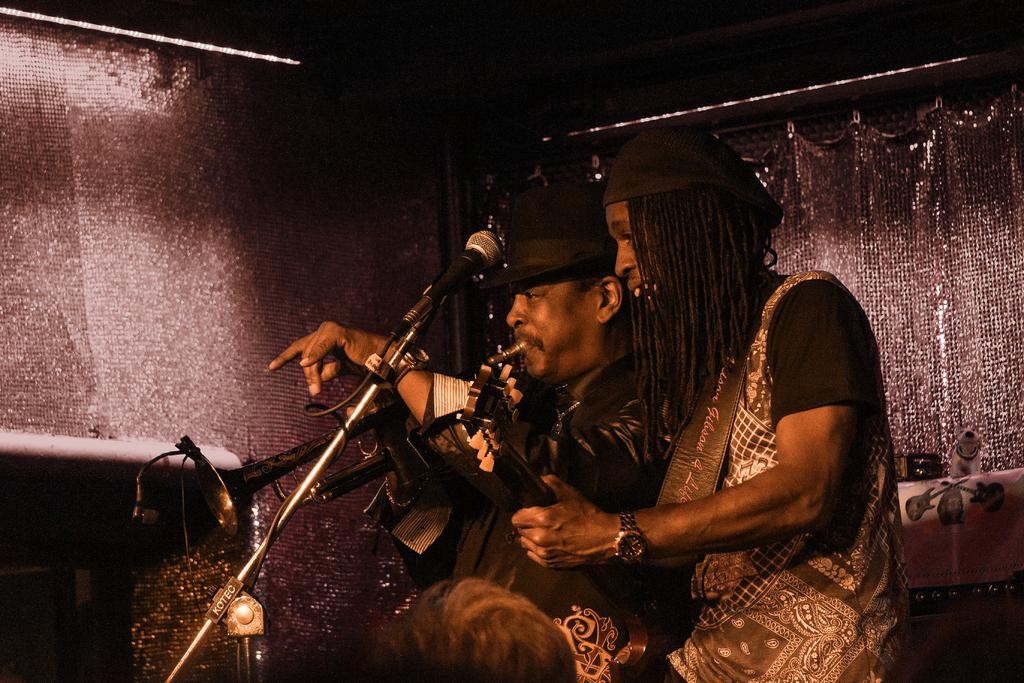What are the two people in the image doing? There is a person playing the guitar and another person playing the trumpet in the image. What might be used for amplifying the sound of their instruments? There is a mic to stand in the image. What is the color of the background in the image? The background of the image is dark. What type of mist can be seen surrounding the person playing the guitar in the image? There is no mist present in the image; it features two people playing musical instruments with a dark background. Can you tell me how many songs the pig is singing in the image? There is no pig present in the image, and therefore no such activity can be observed. 